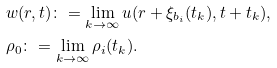<formula> <loc_0><loc_0><loc_500><loc_500>& w ( r , t ) \colon = \lim _ { k \to \infty } u ( r + \xi _ { b _ { i } } ( t _ { k } ) , t + t _ { k } ) , \\ & \rho _ { 0 } \colon = \lim _ { k \to \infty } \rho _ { i } ( t _ { k } ) .</formula> 